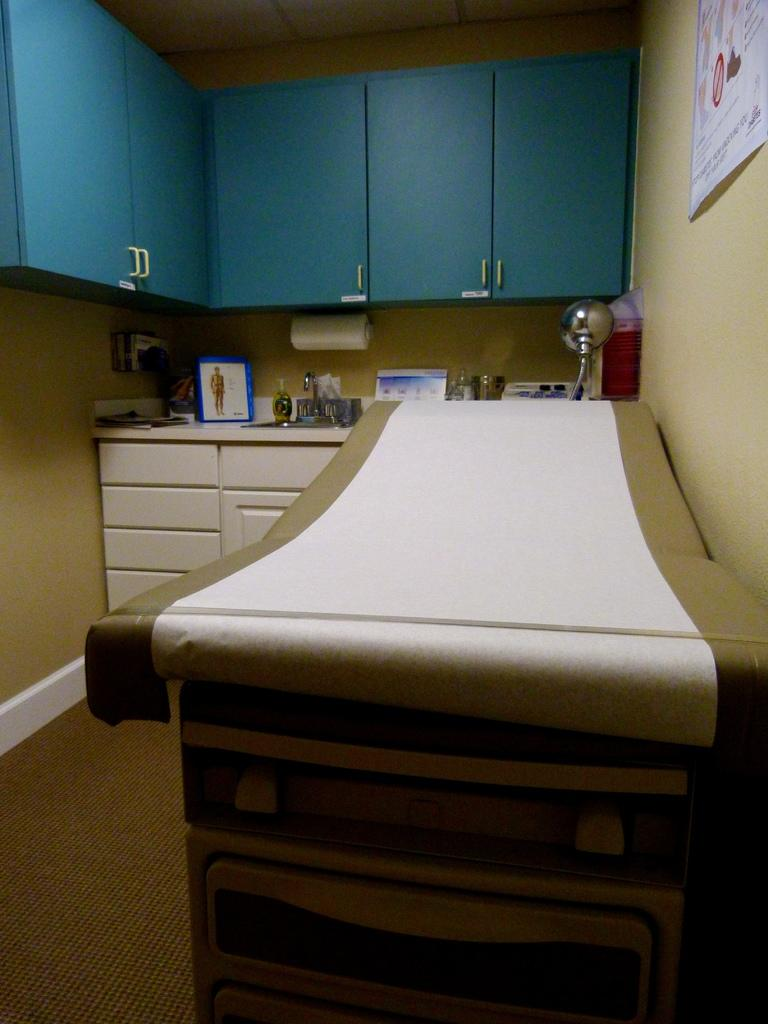What type of furniture is present in the image? There are cupboards in the image. What type of decoration is present on the wall? There is a poster in the image. What type of furniture is used for sleeping in the image? There is a bed in the image. What type of items are used for displaying pictures or artwork in the image? There are frames present in the image. What type of item is used for wiping or blowing one's nose in the image? There is a tissue roll in the image. What type of surface is visible in the image? The floor is visible in the image. What type of structure is present in the image? There is a wall in the image. What type of smell can be detected from the minister in the image? There is no minister present in the image, so it is not possible to detect any smell. What type of attempt is being made by the person in the image? There is no person attempting anything in the image; it only shows various objects and furniture. 